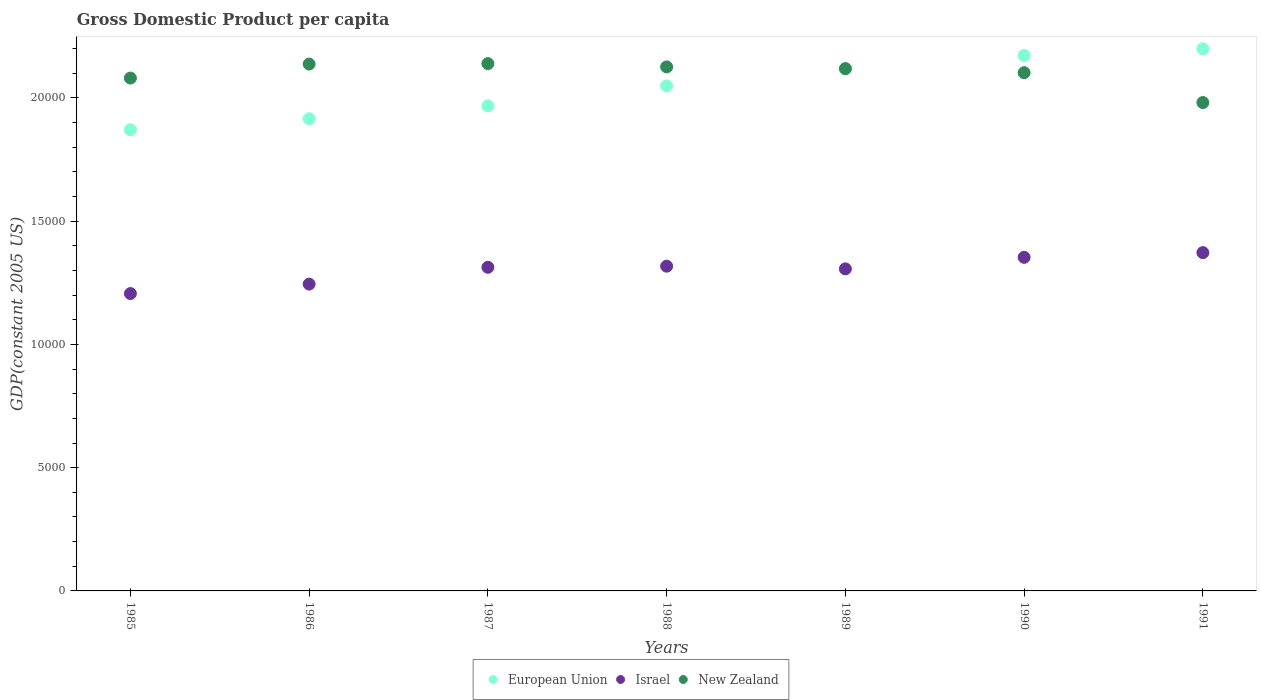Is the number of dotlines equal to the number of legend labels?
Keep it short and to the point. Yes. What is the GDP per capita in Israel in 1985?
Keep it short and to the point. 1.21e+04. Across all years, what is the maximum GDP per capita in Israel?
Give a very brief answer. 1.37e+04. Across all years, what is the minimum GDP per capita in European Union?
Give a very brief answer. 1.87e+04. What is the total GDP per capita in European Union in the graph?
Your answer should be very brief. 1.43e+05. What is the difference between the GDP per capita in European Union in 1985 and that in 1987?
Make the answer very short. -969.66. What is the difference between the GDP per capita in Israel in 1991 and the GDP per capita in New Zealand in 1988?
Provide a short and direct response. -7535.72. What is the average GDP per capita in European Union per year?
Your answer should be compact. 2.04e+04. In the year 1990, what is the difference between the GDP per capita in European Union and GDP per capita in New Zealand?
Your response must be concise. 696.76. What is the ratio of the GDP per capita in New Zealand in 1986 to that in 1987?
Offer a terse response. 1. What is the difference between the highest and the second highest GDP per capita in New Zealand?
Your answer should be very brief. 18.62. What is the difference between the highest and the lowest GDP per capita in New Zealand?
Give a very brief answer. 1580.13. In how many years, is the GDP per capita in New Zealand greater than the average GDP per capita in New Zealand taken over all years?
Offer a very short reply. 5. Is it the case that in every year, the sum of the GDP per capita in New Zealand and GDP per capita in Israel  is greater than the GDP per capita in European Union?
Provide a succinct answer. Yes. Is the GDP per capita in European Union strictly less than the GDP per capita in New Zealand over the years?
Keep it short and to the point. No. How many dotlines are there?
Keep it short and to the point. 3. What is the difference between two consecutive major ticks on the Y-axis?
Make the answer very short. 5000. Does the graph contain any zero values?
Provide a short and direct response. No. Does the graph contain grids?
Keep it short and to the point. No. How are the legend labels stacked?
Ensure brevity in your answer.  Horizontal. What is the title of the graph?
Keep it short and to the point. Gross Domestic Product per capita. What is the label or title of the X-axis?
Provide a succinct answer. Years. What is the label or title of the Y-axis?
Provide a succinct answer. GDP(constant 2005 US). What is the GDP(constant 2005 US) in European Union in 1985?
Provide a short and direct response. 1.87e+04. What is the GDP(constant 2005 US) of Israel in 1985?
Your response must be concise. 1.21e+04. What is the GDP(constant 2005 US) of New Zealand in 1985?
Your answer should be very brief. 2.08e+04. What is the GDP(constant 2005 US) in European Union in 1986?
Offer a very short reply. 1.92e+04. What is the GDP(constant 2005 US) in Israel in 1986?
Offer a terse response. 1.24e+04. What is the GDP(constant 2005 US) in New Zealand in 1986?
Give a very brief answer. 2.14e+04. What is the GDP(constant 2005 US) in European Union in 1987?
Offer a very short reply. 1.97e+04. What is the GDP(constant 2005 US) of Israel in 1987?
Your response must be concise. 1.31e+04. What is the GDP(constant 2005 US) in New Zealand in 1987?
Provide a short and direct response. 2.14e+04. What is the GDP(constant 2005 US) in European Union in 1988?
Your response must be concise. 2.05e+04. What is the GDP(constant 2005 US) in Israel in 1988?
Your response must be concise. 1.32e+04. What is the GDP(constant 2005 US) in New Zealand in 1988?
Keep it short and to the point. 2.13e+04. What is the GDP(constant 2005 US) of European Union in 1989?
Make the answer very short. 2.12e+04. What is the GDP(constant 2005 US) of Israel in 1989?
Make the answer very short. 1.31e+04. What is the GDP(constant 2005 US) in New Zealand in 1989?
Keep it short and to the point. 2.12e+04. What is the GDP(constant 2005 US) of European Union in 1990?
Your answer should be very brief. 2.17e+04. What is the GDP(constant 2005 US) of Israel in 1990?
Your response must be concise. 1.35e+04. What is the GDP(constant 2005 US) in New Zealand in 1990?
Offer a terse response. 2.10e+04. What is the GDP(constant 2005 US) in European Union in 1991?
Provide a succinct answer. 2.20e+04. What is the GDP(constant 2005 US) in Israel in 1991?
Provide a short and direct response. 1.37e+04. What is the GDP(constant 2005 US) in New Zealand in 1991?
Make the answer very short. 1.98e+04. Across all years, what is the maximum GDP(constant 2005 US) in European Union?
Provide a short and direct response. 2.20e+04. Across all years, what is the maximum GDP(constant 2005 US) in Israel?
Keep it short and to the point. 1.37e+04. Across all years, what is the maximum GDP(constant 2005 US) of New Zealand?
Make the answer very short. 2.14e+04. Across all years, what is the minimum GDP(constant 2005 US) in European Union?
Provide a short and direct response. 1.87e+04. Across all years, what is the minimum GDP(constant 2005 US) in Israel?
Give a very brief answer. 1.21e+04. Across all years, what is the minimum GDP(constant 2005 US) in New Zealand?
Make the answer very short. 1.98e+04. What is the total GDP(constant 2005 US) of European Union in the graph?
Keep it short and to the point. 1.43e+05. What is the total GDP(constant 2005 US) of Israel in the graph?
Provide a succinct answer. 9.11e+04. What is the total GDP(constant 2005 US) of New Zealand in the graph?
Ensure brevity in your answer.  1.47e+05. What is the difference between the GDP(constant 2005 US) in European Union in 1985 and that in 1986?
Your response must be concise. -447.36. What is the difference between the GDP(constant 2005 US) of Israel in 1985 and that in 1986?
Ensure brevity in your answer.  -383.98. What is the difference between the GDP(constant 2005 US) in New Zealand in 1985 and that in 1986?
Provide a succinct answer. -568.27. What is the difference between the GDP(constant 2005 US) in European Union in 1985 and that in 1987?
Your response must be concise. -969.66. What is the difference between the GDP(constant 2005 US) of Israel in 1985 and that in 1987?
Your response must be concise. -1064.96. What is the difference between the GDP(constant 2005 US) in New Zealand in 1985 and that in 1987?
Offer a terse response. -586.89. What is the difference between the GDP(constant 2005 US) of European Union in 1985 and that in 1988?
Offer a terse response. -1780.6. What is the difference between the GDP(constant 2005 US) of Israel in 1985 and that in 1988?
Keep it short and to the point. -1110.59. What is the difference between the GDP(constant 2005 US) in New Zealand in 1985 and that in 1988?
Offer a terse response. -453.34. What is the difference between the GDP(constant 2005 US) of European Union in 1985 and that in 1989?
Your answer should be compact. -2465.99. What is the difference between the GDP(constant 2005 US) of Israel in 1985 and that in 1989?
Offer a very short reply. -1001.54. What is the difference between the GDP(constant 2005 US) in New Zealand in 1985 and that in 1989?
Your answer should be very brief. -384.57. What is the difference between the GDP(constant 2005 US) in European Union in 1985 and that in 1990?
Make the answer very short. -3013.55. What is the difference between the GDP(constant 2005 US) in Israel in 1985 and that in 1990?
Give a very brief answer. -1469.31. What is the difference between the GDP(constant 2005 US) in New Zealand in 1985 and that in 1990?
Offer a terse response. -219.22. What is the difference between the GDP(constant 2005 US) of European Union in 1985 and that in 1991?
Offer a very short reply. -3284.95. What is the difference between the GDP(constant 2005 US) of Israel in 1985 and that in 1991?
Keep it short and to the point. -1660.17. What is the difference between the GDP(constant 2005 US) of New Zealand in 1985 and that in 1991?
Your answer should be compact. 993.24. What is the difference between the GDP(constant 2005 US) of European Union in 1986 and that in 1987?
Give a very brief answer. -522.3. What is the difference between the GDP(constant 2005 US) of Israel in 1986 and that in 1987?
Give a very brief answer. -680.99. What is the difference between the GDP(constant 2005 US) of New Zealand in 1986 and that in 1987?
Ensure brevity in your answer.  -18.62. What is the difference between the GDP(constant 2005 US) of European Union in 1986 and that in 1988?
Provide a short and direct response. -1333.24. What is the difference between the GDP(constant 2005 US) in Israel in 1986 and that in 1988?
Provide a short and direct response. -726.61. What is the difference between the GDP(constant 2005 US) in New Zealand in 1986 and that in 1988?
Give a very brief answer. 114.93. What is the difference between the GDP(constant 2005 US) in European Union in 1986 and that in 1989?
Your answer should be compact. -2018.63. What is the difference between the GDP(constant 2005 US) in Israel in 1986 and that in 1989?
Your answer should be very brief. -617.56. What is the difference between the GDP(constant 2005 US) in New Zealand in 1986 and that in 1989?
Make the answer very short. 183.7. What is the difference between the GDP(constant 2005 US) of European Union in 1986 and that in 1990?
Offer a very short reply. -2566.19. What is the difference between the GDP(constant 2005 US) in Israel in 1986 and that in 1990?
Keep it short and to the point. -1085.33. What is the difference between the GDP(constant 2005 US) of New Zealand in 1986 and that in 1990?
Provide a succinct answer. 349.05. What is the difference between the GDP(constant 2005 US) of European Union in 1986 and that in 1991?
Your response must be concise. -2837.59. What is the difference between the GDP(constant 2005 US) of Israel in 1986 and that in 1991?
Ensure brevity in your answer.  -1276.19. What is the difference between the GDP(constant 2005 US) of New Zealand in 1986 and that in 1991?
Ensure brevity in your answer.  1561.51. What is the difference between the GDP(constant 2005 US) in European Union in 1987 and that in 1988?
Offer a very short reply. -810.94. What is the difference between the GDP(constant 2005 US) of Israel in 1987 and that in 1988?
Give a very brief answer. -45.62. What is the difference between the GDP(constant 2005 US) of New Zealand in 1987 and that in 1988?
Give a very brief answer. 133.55. What is the difference between the GDP(constant 2005 US) in European Union in 1987 and that in 1989?
Offer a terse response. -1496.33. What is the difference between the GDP(constant 2005 US) in Israel in 1987 and that in 1989?
Make the answer very short. 63.42. What is the difference between the GDP(constant 2005 US) in New Zealand in 1987 and that in 1989?
Give a very brief answer. 202.32. What is the difference between the GDP(constant 2005 US) in European Union in 1987 and that in 1990?
Offer a terse response. -2043.89. What is the difference between the GDP(constant 2005 US) in Israel in 1987 and that in 1990?
Provide a succinct answer. -404.35. What is the difference between the GDP(constant 2005 US) of New Zealand in 1987 and that in 1990?
Give a very brief answer. 367.67. What is the difference between the GDP(constant 2005 US) in European Union in 1987 and that in 1991?
Offer a terse response. -2315.29. What is the difference between the GDP(constant 2005 US) in Israel in 1987 and that in 1991?
Ensure brevity in your answer.  -595.2. What is the difference between the GDP(constant 2005 US) in New Zealand in 1987 and that in 1991?
Your response must be concise. 1580.13. What is the difference between the GDP(constant 2005 US) of European Union in 1988 and that in 1989?
Your answer should be compact. -685.39. What is the difference between the GDP(constant 2005 US) in Israel in 1988 and that in 1989?
Make the answer very short. 109.04. What is the difference between the GDP(constant 2005 US) in New Zealand in 1988 and that in 1989?
Your answer should be compact. 68.77. What is the difference between the GDP(constant 2005 US) in European Union in 1988 and that in 1990?
Your answer should be compact. -1232.96. What is the difference between the GDP(constant 2005 US) in Israel in 1988 and that in 1990?
Your answer should be very brief. -358.72. What is the difference between the GDP(constant 2005 US) in New Zealand in 1988 and that in 1990?
Ensure brevity in your answer.  234.12. What is the difference between the GDP(constant 2005 US) in European Union in 1988 and that in 1991?
Give a very brief answer. -1504.35. What is the difference between the GDP(constant 2005 US) of Israel in 1988 and that in 1991?
Ensure brevity in your answer.  -549.58. What is the difference between the GDP(constant 2005 US) in New Zealand in 1988 and that in 1991?
Provide a short and direct response. 1446.58. What is the difference between the GDP(constant 2005 US) of European Union in 1989 and that in 1990?
Your answer should be compact. -547.57. What is the difference between the GDP(constant 2005 US) of Israel in 1989 and that in 1990?
Your response must be concise. -467.77. What is the difference between the GDP(constant 2005 US) in New Zealand in 1989 and that in 1990?
Keep it short and to the point. 165.35. What is the difference between the GDP(constant 2005 US) in European Union in 1989 and that in 1991?
Give a very brief answer. -818.96. What is the difference between the GDP(constant 2005 US) in Israel in 1989 and that in 1991?
Your answer should be very brief. -658.63. What is the difference between the GDP(constant 2005 US) of New Zealand in 1989 and that in 1991?
Your response must be concise. 1377.81. What is the difference between the GDP(constant 2005 US) of European Union in 1990 and that in 1991?
Provide a short and direct response. -271.39. What is the difference between the GDP(constant 2005 US) in Israel in 1990 and that in 1991?
Provide a succinct answer. -190.86. What is the difference between the GDP(constant 2005 US) in New Zealand in 1990 and that in 1991?
Offer a very short reply. 1212.46. What is the difference between the GDP(constant 2005 US) of European Union in 1985 and the GDP(constant 2005 US) of Israel in 1986?
Offer a very short reply. 6261. What is the difference between the GDP(constant 2005 US) in European Union in 1985 and the GDP(constant 2005 US) in New Zealand in 1986?
Offer a terse response. -2665.84. What is the difference between the GDP(constant 2005 US) of Israel in 1985 and the GDP(constant 2005 US) of New Zealand in 1986?
Provide a short and direct response. -9310.82. What is the difference between the GDP(constant 2005 US) in European Union in 1985 and the GDP(constant 2005 US) in Israel in 1987?
Your answer should be compact. 5580.02. What is the difference between the GDP(constant 2005 US) of European Union in 1985 and the GDP(constant 2005 US) of New Zealand in 1987?
Ensure brevity in your answer.  -2684.46. What is the difference between the GDP(constant 2005 US) in Israel in 1985 and the GDP(constant 2005 US) in New Zealand in 1987?
Provide a short and direct response. -9329.44. What is the difference between the GDP(constant 2005 US) in European Union in 1985 and the GDP(constant 2005 US) in Israel in 1988?
Ensure brevity in your answer.  5534.39. What is the difference between the GDP(constant 2005 US) of European Union in 1985 and the GDP(constant 2005 US) of New Zealand in 1988?
Your answer should be compact. -2550.91. What is the difference between the GDP(constant 2005 US) in Israel in 1985 and the GDP(constant 2005 US) in New Zealand in 1988?
Offer a very short reply. -9195.89. What is the difference between the GDP(constant 2005 US) in European Union in 1985 and the GDP(constant 2005 US) in Israel in 1989?
Your answer should be compact. 5643.44. What is the difference between the GDP(constant 2005 US) of European Union in 1985 and the GDP(constant 2005 US) of New Zealand in 1989?
Offer a very short reply. -2482.14. What is the difference between the GDP(constant 2005 US) in Israel in 1985 and the GDP(constant 2005 US) in New Zealand in 1989?
Make the answer very short. -9127.12. What is the difference between the GDP(constant 2005 US) in European Union in 1985 and the GDP(constant 2005 US) in Israel in 1990?
Provide a succinct answer. 5175.67. What is the difference between the GDP(constant 2005 US) in European Union in 1985 and the GDP(constant 2005 US) in New Zealand in 1990?
Provide a succinct answer. -2316.79. What is the difference between the GDP(constant 2005 US) of Israel in 1985 and the GDP(constant 2005 US) of New Zealand in 1990?
Provide a succinct answer. -8961.77. What is the difference between the GDP(constant 2005 US) in European Union in 1985 and the GDP(constant 2005 US) in Israel in 1991?
Offer a terse response. 4984.81. What is the difference between the GDP(constant 2005 US) of European Union in 1985 and the GDP(constant 2005 US) of New Zealand in 1991?
Your answer should be compact. -1104.33. What is the difference between the GDP(constant 2005 US) in Israel in 1985 and the GDP(constant 2005 US) in New Zealand in 1991?
Offer a very short reply. -7749.31. What is the difference between the GDP(constant 2005 US) in European Union in 1986 and the GDP(constant 2005 US) in Israel in 1987?
Keep it short and to the point. 6027.37. What is the difference between the GDP(constant 2005 US) of European Union in 1986 and the GDP(constant 2005 US) of New Zealand in 1987?
Give a very brief answer. -2237.1. What is the difference between the GDP(constant 2005 US) in Israel in 1986 and the GDP(constant 2005 US) in New Zealand in 1987?
Offer a very short reply. -8945.46. What is the difference between the GDP(constant 2005 US) of European Union in 1986 and the GDP(constant 2005 US) of Israel in 1988?
Your answer should be very brief. 5981.75. What is the difference between the GDP(constant 2005 US) in European Union in 1986 and the GDP(constant 2005 US) in New Zealand in 1988?
Provide a succinct answer. -2103.56. What is the difference between the GDP(constant 2005 US) of Israel in 1986 and the GDP(constant 2005 US) of New Zealand in 1988?
Make the answer very short. -8811.92. What is the difference between the GDP(constant 2005 US) in European Union in 1986 and the GDP(constant 2005 US) in Israel in 1989?
Give a very brief answer. 6090.8. What is the difference between the GDP(constant 2005 US) in European Union in 1986 and the GDP(constant 2005 US) in New Zealand in 1989?
Offer a very short reply. -2034.79. What is the difference between the GDP(constant 2005 US) of Israel in 1986 and the GDP(constant 2005 US) of New Zealand in 1989?
Offer a very short reply. -8743.15. What is the difference between the GDP(constant 2005 US) of European Union in 1986 and the GDP(constant 2005 US) of Israel in 1990?
Offer a very short reply. 5623.03. What is the difference between the GDP(constant 2005 US) of European Union in 1986 and the GDP(constant 2005 US) of New Zealand in 1990?
Give a very brief answer. -1869.43. What is the difference between the GDP(constant 2005 US) in Israel in 1986 and the GDP(constant 2005 US) in New Zealand in 1990?
Provide a short and direct response. -8577.79. What is the difference between the GDP(constant 2005 US) in European Union in 1986 and the GDP(constant 2005 US) in Israel in 1991?
Your answer should be compact. 5432.17. What is the difference between the GDP(constant 2005 US) in European Union in 1986 and the GDP(constant 2005 US) in New Zealand in 1991?
Give a very brief answer. -656.97. What is the difference between the GDP(constant 2005 US) of Israel in 1986 and the GDP(constant 2005 US) of New Zealand in 1991?
Make the answer very short. -7365.33. What is the difference between the GDP(constant 2005 US) in European Union in 1987 and the GDP(constant 2005 US) in Israel in 1988?
Your answer should be compact. 6504.05. What is the difference between the GDP(constant 2005 US) of European Union in 1987 and the GDP(constant 2005 US) of New Zealand in 1988?
Offer a terse response. -1581.26. What is the difference between the GDP(constant 2005 US) in Israel in 1987 and the GDP(constant 2005 US) in New Zealand in 1988?
Your response must be concise. -8130.93. What is the difference between the GDP(constant 2005 US) of European Union in 1987 and the GDP(constant 2005 US) of Israel in 1989?
Provide a succinct answer. 6613.1. What is the difference between the GDP(constant 2005 US) of European Union in 1987 and the GDP(constant 2005 US) of New Zealand in 1989?
Ensure brevity in your answer.  -1512.49. What is the difference between the GDP(constant 2005 US) of Israel in 1987 and the GDP(constant 2005 US) of New Zealand in 1989?
Provide a short and direct response. -8062.16. What is the difference between the GDP(constant 2005 US) in European Union in 1987 and the GDP(constant 2005 US) in Israel in 1990?
Your response must be concise. 6145.33. What is the difference between the GDP(constant 2005 US) of European Union in 1987 and the GDP(constant 2005 US) of New Zealand in 1990?
Keep it short and to the point. -1347.13. What is the difference between the GDP(constant 2005 US) of Israel in 1987 and the GDP(constant 2005 US) of New Zealand in 1990?
Provide a short and direct response. -7896.81. What is the difference between the GDP(constant 2005 US) of European Union in 1987 and the GDP(constant 2005 US) of Israel in 1991?
Keep it short and to the point. 5954.47. What is the difference between the GDP(constant 2005 US) in European Union in 1987 and the GDP(constant 2005 US) in New Zealand in 1991?
Your answer should be compact. -134.67. What is the difference between the GDP(constant 2005 US) in Israel in 1987 and the GDP(constant 2005 US) in New Zealand in 1991?
Offer a terse response. -6684.35. What is the difference between the GDP(constant 2005 US) of European Union in 1988 and the GDP(constant 2005 US) of Israel in 1989?
Provide a succinct answer. 7424.03. What is the difference between the GDP(constant 2005 US) in European Union in 1988 and the GDP(constant 2005 US) in New Zealand in 1989?
Your response must be concise. -701.55. What is the difference between the GDP(constant 2005 US) of Israel in 1988 and the GDP(constant 2005 US) of New Zealand in 1989?
Offer a very short reply. -8016.54. What is the difference between the GDP(constant 2005 US) of European Union in 1988 and the GDP(constant 2005 US) of Israel in 1990?
Offer a terse response. 6956.26. What is the difference between the GDP(constant 2005 US) in European Union in 1988 and the GDP(constant 2005 US) in New Zealand in 1990?
Make the answer very short. -536.2. What is the difference between the GDP(constant 2005 US) of Israel in 1988 and the GDP(constant 2005 US) of New Zealand in 1990?
Offer a terse response. -7851.18. What is the difference between the GDP(constant 2005 US) of European Union in 1988 and the GDP(constant 2005 US) of Israel in 1991?
Ensure brevity in your answer.  6765.41. What is the difference between the GDP(constant 2005 US) of European Union in 1988 and the GDP(constant 2005 US) of New Zealand in 1991?
Provide a short and direct response. 676.26. What is the difference between the GDP(constant 2005 US) of Israel in 1988 and the GDP(constant 2005 US) of New Zealand in 1991?
Provide a succinct answer. -6638.73. What is the difference between the GDP(constant 2005 US) of European Union in 1989 and the GDP(constant 2005 US) of Israel in 1990?
Make the answer very short. 7641.65. What is the difference between the GDP(constant 2005 US) in European Union in 1989 and the GDP(constant 2005 US) in New Zealand in 1990?
Offer a very short reply. 149.19. What is the difference between the GDP(constant 2005 US) in Israel in 1989 and the GDP(constant 2005 US) in New Zealand in 1990?
Provide a succinct answer. -7960.23. What is the difference between the GDP(constant 2005 US) in European Union in 1989 and the GDP(constant 2005 US) in Israel in 1991?
Make the answer very short. 7450.8. What is the difference between the GDP(constant 2005 US) of European Union in 1989 and the GDP(constant 2005 US) of New Zealand in 1991?
Give a very brief answer. 1361.65. What is the difference between the GDP(constant 2005 US) in Israel in 1989 and the GDP(constant 2005 US) in New Zealand in 1991?
Your answer should be compact. -6747.77. What is the difference between the GDP(constant 2005 US) of European Union in 1990 and the GDP(constant 2005 US) of Israel in 1991?
Offer a very short reply. 7998.36. What is the difference between the GDP(constant 2005 US) in European Union in 1990 and the GDP(constant 2005 US) in New Zealand in 1991?
Your answer should be very brief. 1909.22. What is the difference between the GDP(constant 2005 US) in Israel in 1990 and the GDP(constant 2005 US) in New Zealand in 1991?
Offer a very short reply. -6280. What is the average GDP(constant 2005 US) of European Union per year?
Your answer should be very brief. 2.04e+04. What is the average GDP(constant 2005 US) in Israel per year?
Your answer should be compact. 1.30e+04. What is the average GDP(constant 2005 US) in New Zealand per year?
Your response must be concise. 2.10e+04. In the year 1985, what is the difference between the GDP(constant 2005 US) of European Union and GDP(constant 2005 US) of Israel?
Provide a succinct answer. 6644.98. In the year 1985, what is the difference between the GDP(constant 2005 US) in European Union and GDP(constant 2005 US) in New Zealand?
Keep it short and to the point. -2097.57. In the year 1985, what is the difference between the GDP(constant 2005 US) in Israel and GDP(constant 2005 US) in New Zealand?
Your answer should be compact. -8742.55. In the year 1986, what is the difference between the GDP(constant 2005 US) of European Union and GDP(constant 2005 US) of Israel?
Keep it short and to the point. 6708.36. In the year 1986, what is the difference between the GDP(constant 2005 US) in European Union and GDP(constant 2005 US) in New Zealand?
Your answer should be compact. -2218.48. In the year 1986, what is the difference between the GDP(constant 2005 US) of Israel and GDP(constant 2005 US) of New Zealand?
Offer a very short reply. -8926.84. In the year 1987, what is the difference between the GDP(constant 2005 US) of European Union and GDP(constant 2005 US) of Israel?
Keep it short and to the point. 6549.67. In the year 1987, what is the difference between the GDP(constant 2005 US) in European Union and GDP(constant 2005 US) in New Zealand?
Provide a succinct answer. -1714.8. In the year 1987, what is the difference between the GDP(constant 2005 US) in Israel and GDP(constant 2005 US) in New Zealand?
Provide a short and direct response. -8264.48. In the year 1988, what is the difference between the GDP(constant 2005 US) in European Union and GDP(constant 2005 US) in Israel?
Make the answer very short. 7314.99. In the year 1988, what is the difference between the GDP(constant 2005 US) in European Union and GDP(constant 2005 US) in New Zealand?
Provide a short and direct response. -770.32. In the year 1988, what is the difference between the GDP(constant 2005 US) in Israel and GDP(constant 2005 US) in New Zealand?
Your answer should be compact. -8085.31. In the year 1989, what is the difference between the GDP(constant 2005 US) in European Union and GDP(constant 2005 US) in Israel?
Make the answer very short. 8109.42. In the year 1989, what is the difference between the GDP(constant 2005 US) of European Union and GDP(constant 2005 US) of New Zealand?
Provide a succinct answer. -16.16. In the year 1989, what is the difference between the GDP(constant 2005 US) of Israel and GDP(constant 2005 US) of New Zealand?
Give a very brief answer. -8125.58. In the year 1990, what is the difference between the GDP(constant 2005 US) of European Union and GDP(constant 2005 US) of Israel?
Give a very brief answer. 8189.22. In the year 1990, what is the difference between the GDP(constant 2005 US) in European Union and GDP(constant 2005 US) in New Zealand?
Provide a succinct answer. 696.76. In the year 1990, what is the difference between the GDP(constant 2005 US) in Israel and GDP(constant 2005 US) in New Zealand?
Make the answer very short. -7492.46. In the year 1991, what is the difference between the GDP(constant 2005 US) in European Union and GDP(constant 2005 US) in Israel?
Keep it short and to the point. 8269.76. In the year 1991, what is the difference between the GDP(constant 2005 US) in European Union and GDP(constant 2005 US) in New Zealand?
Ensure brevity in your answer.  2180.61. In the year 1991, what is the difference between the GDP(constant 2005 US) in Israel and GDP(constant 2005 US) in New Zealand?
Keep it short and to the point. -6089.14. What is the ratio of the GDP(constant 2005 US) of European Union in 1985 to that in 1986?
Give a very brief answer. 0.98. What is the ratio of the GDP(constant 2005 US) of Israel in 1985 to that in 1986?
Give a very brief answer. 0.97. What is the ratio of the GDP(constant 2005 US) in New Zealand in 1985 to that in 1986?
Your answer should be very brief. 0.97. What is the ratio of the GDP(constant 2005 US) of European Union in 1985 to that in 1987?
Keep it short and to the point. 0.95. What is the ratio of the GDP(constant 2005 US) in Israel in 1985 to that in 1987?
Your answer should be compact. 0.92. What is the ratio of the GDP(constant 2005 US) in New Zealand in 1985 to that in 1987?
Keep it short and to the point. 0.97. What is the ratio of the GDP(constant 2005 US) in European Union in 1985 to that in 1988?
Keep it short and to the point. 0.91. What is the ratio of the GDP(constant 2005 US) of Israel in 1985 to that in 1988?
Your response must be concise. 0.92. What is the ratio of the GDP(constant 2005 US) of New Zealand in 1985 to that in 1988?
Offer a terse response. 0.98. What is the ratio of the GDP(constant 2005 US) in European Union in 1985 to that in 1989?
Your answer should be compact. 0.88. What is the ratio of the GDP(constant 2005 US) in Israel in 1985 to that in 1989?
Keep it short and to the point. 0.92. What is the ratio of the GDP(constant 2005 US) in New Zealand in 1985 to that in 1989?
Provide a short and direct response. 0.98. What is the ratio of the GDP(constant 2005 US) of European Union in 1985 to that in 1990?
Provide a short and direct response. 0.86. What is the ratio of the GDP(constant 2005 US) in Israel in 1985 to that in 1990?
Offer a very short reply. 0.89. What is the ratio of the GDP(constant 2005 US) in European Union in 1985 to that in 1991?
Provide a succinct answer. 0.85. What is the ratio of the GDP(constant 2005 US) in Israel in 1985 to that in 1991?
Offer a very short reply. 0.88. What is the ratio of the GDP(constant 2005 US) of New Zealand in 1985 to that in 1991?
Provide a succinct answer. 1.05. What is the ratio of the GDP(constant 2005 US) of European Union in 1986 to that in 1987?
Provide a short and direct response. 0.97. What is the ratio of the GDP(constant 2005 US) in Israel in 1986 to that in 1987?
Your response must be concise. 0.95. What is the ratio of the GDP(constant 2005 US) in New Zealand in 1986 to that in 1987?
Offer a very short reply. 1. What is the ratio of the GDP(constant 2005 US) in European Union in 1986 to that in 1988?
Give a very brief answer. 0.93. What is the ratio of the GDP(constant 2005 US) of Israel in 1986 to that in 1988?
Ensure brevity in your answer.  0.94. What is the ratio of the GDP(constant 2005 US) in New Zealand in 1986 to that in 1988?
Your answer should be compact. 1.01. What is the ratio of the GDP(constant 2005 US) in European Union in 1986 to that in 1989?
Provide a short and direct response. 0.9. What is the ratio of the GDP(constant 2005 US) of Israel in 1986 to that in 1989?
Your response must be concise. 0.95. What is the ratio of the GDP(constant 2005 US) in New Zealand in 1986 to that in 1989?
Your answer should be compact. 1.01. What is the ratio of the GDP(constant 2005 US) of European Union in 1986 to that in 1990?
Your answer should be very brief. 0.88. What is the ratio of the GDP(constant 2005 US) in Israel in 1986 to that in 1990?
Give a very brief answer. 0.92. What is the ratio of the GDP(constant 2005 US) in New Zealand in 1986 to that in 1990?
Provide a short and direct response. 1.02. What is the ratio of the GDP(constant 2005 US) of European Union in 1986 to that in 1991?
Ensure brevity in your answer.  0.87. What is the ratio of the GDP(constant 2005 US) in Israel in 1986 to that in 1991?
Provide a short and direct response. 0.91. What is the ratio of the GDP(constant 2005 US) in New Zealand in 1986 to that in 1991?
Offer a terse response. 1.08. What is the ratio of the GDP(constant 2005 US) of European Union in 1987 to that in 1988?
Provide a succinct answer. 0.96. What is the ratio of the GDP(constant 2005 US) of Israel in 1987 to that in 1988?
Make the answer very short. 1. What is the ratio of the GDP(constant 2005 US) in European Union in 1987 to that in 1989?
Make the answer very short. 0.93. What is the ratio of the GDP(constant 2005 US) of Israel in 1987 to that in 1989?
Provide a short and direct response. 1. What is the ratio of the GDP(constant 2005 US) in New Zealand in 1987 to that in 1989?
Keep it short and to the point. 1.01. What is the ratio of the GDP(constant 2005 US) of European Union in 1987 to that in 1990?
Make the answer very short. 0.91. What is the ratio of the GDP(constant 2005 US) in Israel in 1987 to that in 1990?
Your response must be concise. 0.97. What is the ratio of the GDP(constant 2005 US) of New Zealand in 1987 to that in 1990?
Your answer should be compact. 1.02. What is the ratio of the GDP(constant 2005 US) in European Union in 1987 to that in 1991?
Ensure brevity in your answer.  0.89. What is the ratio of the GDP(constant 2005 US) in Israel in 1987 to that in 1991?
Your answer should be compact. 0.96. What is the ratio of the GDP(constant 2005 US) of New Zealand in 1987 to that in 1991?
Offer a very short reply. 1.08. What is the ratio of the GDP(constant 2005 US) in European Union in 1988 to that in 1989?
Offer a very short reply. 0.97. What is the ratio of the GDP(constant 2005 US) of Israel in 1988 to that in 1989?
Offer a very short reply. 1.01. What is the ratio of the GDP(constant 2005 US) in New Zealand in 1988 to that in 1989?
Your answer should be very brief. 1. What is the ratio of the GDP(constant 2005 US) in European Union in 1988 to that in 1990?
Provide a succinct answer. 0.94. What is the ratio of the GDP(constant 2005 US) of Israel in 1988 to that in 1990?
Your answer should be very brief. 0.97. What is the ratio of the GDP(constant 2005 US) in New Zealand in 1988 to that in 1990?
Provide a succinct answer. 1.01. What is the ratio of the GDP(constant 2005 US) of European Union in 1988 to that in 1991?
Give a very brief answer. 0.93. What is the ratio of the GDP(constant 2005 US) in New Zealand in 1988 to that in 1991?
Offer a terse response. 1.07. What is the ratio of the GDP(constant 2005 US) in European Union in 1989 to that in 1990?
Your response must be concise. 0.97. What is the ratio of the GDP(constant 2005 US) of Israel in 1989 to that in 1990?
Keep it short and to the point. 0.97. What is the ratio of the GDP(constant 2005 US) of New Zealand in 1989 to that in 1990?
Keep it short and to the point. 1.01. What is the ratio of the GDP(constant 2005 US) of European Union in 1989 to that in 1991?
Your answer should be very brief. 0.96. What is the ratio of the GDP(constant 2005 US) in Israel in 1989 to that in 1991?
Your answer should be compact. 0.95. What is the ratio of the GDP(constant 2005 US) in New Zealand in 1989 to that in 1991?
Give a very brief answer. 1.07. What is the ratio of the GDP(constant 2005 US) of Israel in 1990 to that in 1991?
Keep it short and to the point. 0.99. What is the ratio of the GDP(constant 2005 US) in New Zealand in 1990 to that in 1991?
Give a very brief answer. 1.06. What is the difference between the highest and the second highest GDP(constant 2005 US) in European Union?
Your answer should be compact. 271.39. What is the difference between the highest and the second highest GDP(constant 2005 US) in Israel?
Provide a short and direct response. 190.86. What is the difference between the highest and the second highest GDP(constant 2005 US) in New Zealand?
Provide a succinct answer. 18.62. What is the difference between the highest and the lowest GDP(constant 2005 US) in European Union?
Give a very brief answer. 3284.95. What is the difference between the highest and the lowest GDP(constant 2005 US) of Israel?
Make the answer very short. 1660.17. What is the difference between the highest and the lowest GDP(constant 2005 US) in New Zealand?
Provide a succinct answer. 1580.13. 